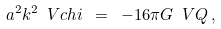Convert formula to latex. <formula><loc_0><loc_0><loc_500><loc_500>a ^ { 2 } k ^ { 2 } \ V c h i \ = \ - 1 6 \pi G \ V { Q } \, ,</formula> 